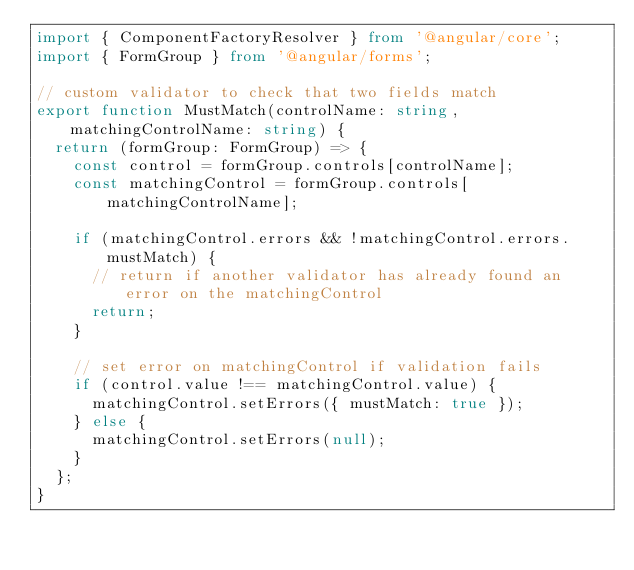Convert code to text. <code><loc_0><loc_0><loc_500><loc_500><_TypeScript_>import { ComponentFactoryResolver } from '@angular/core';
import { FormGroup } from '@angular/forms';

// custom validator to check that two fields match
export function MustMatch(controlName: string, matchingControlName: string) {
  return (formGroup: FormGroup) => {
    const control = formGroup.controls[controlName];
    const matchingControl = formGroup.controls[matchingControlName];

    if (matchingControl.errors && !matchingControl.errors.mustMatch) {
      // return if another validator has already found an error on the matchingControl
      return;
    }

    // set error on matchingControl if validation fails
    if (control.value !== matchingControl.value) {
      matchingControl.setErrors({ mustMatch: true });
    } else {
      matchingControl.setErrors(null);
    }
  };
}
</code> 